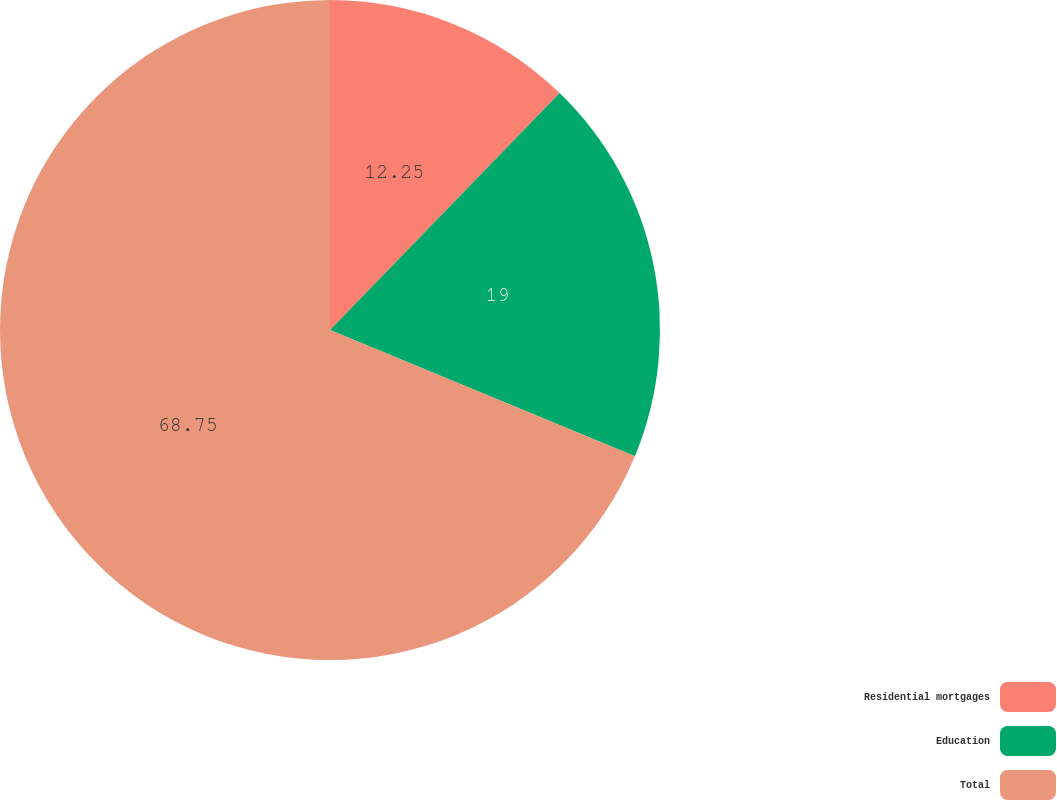<chart> <loc_0><loc_0><loc_500><loc_500><pie_chart><fcel>Residential mortgages<fcel>Education<fcel>Total<nl><fcel>12.25%<fcel>19.0%<fcel>68.75%<nl></chart> 